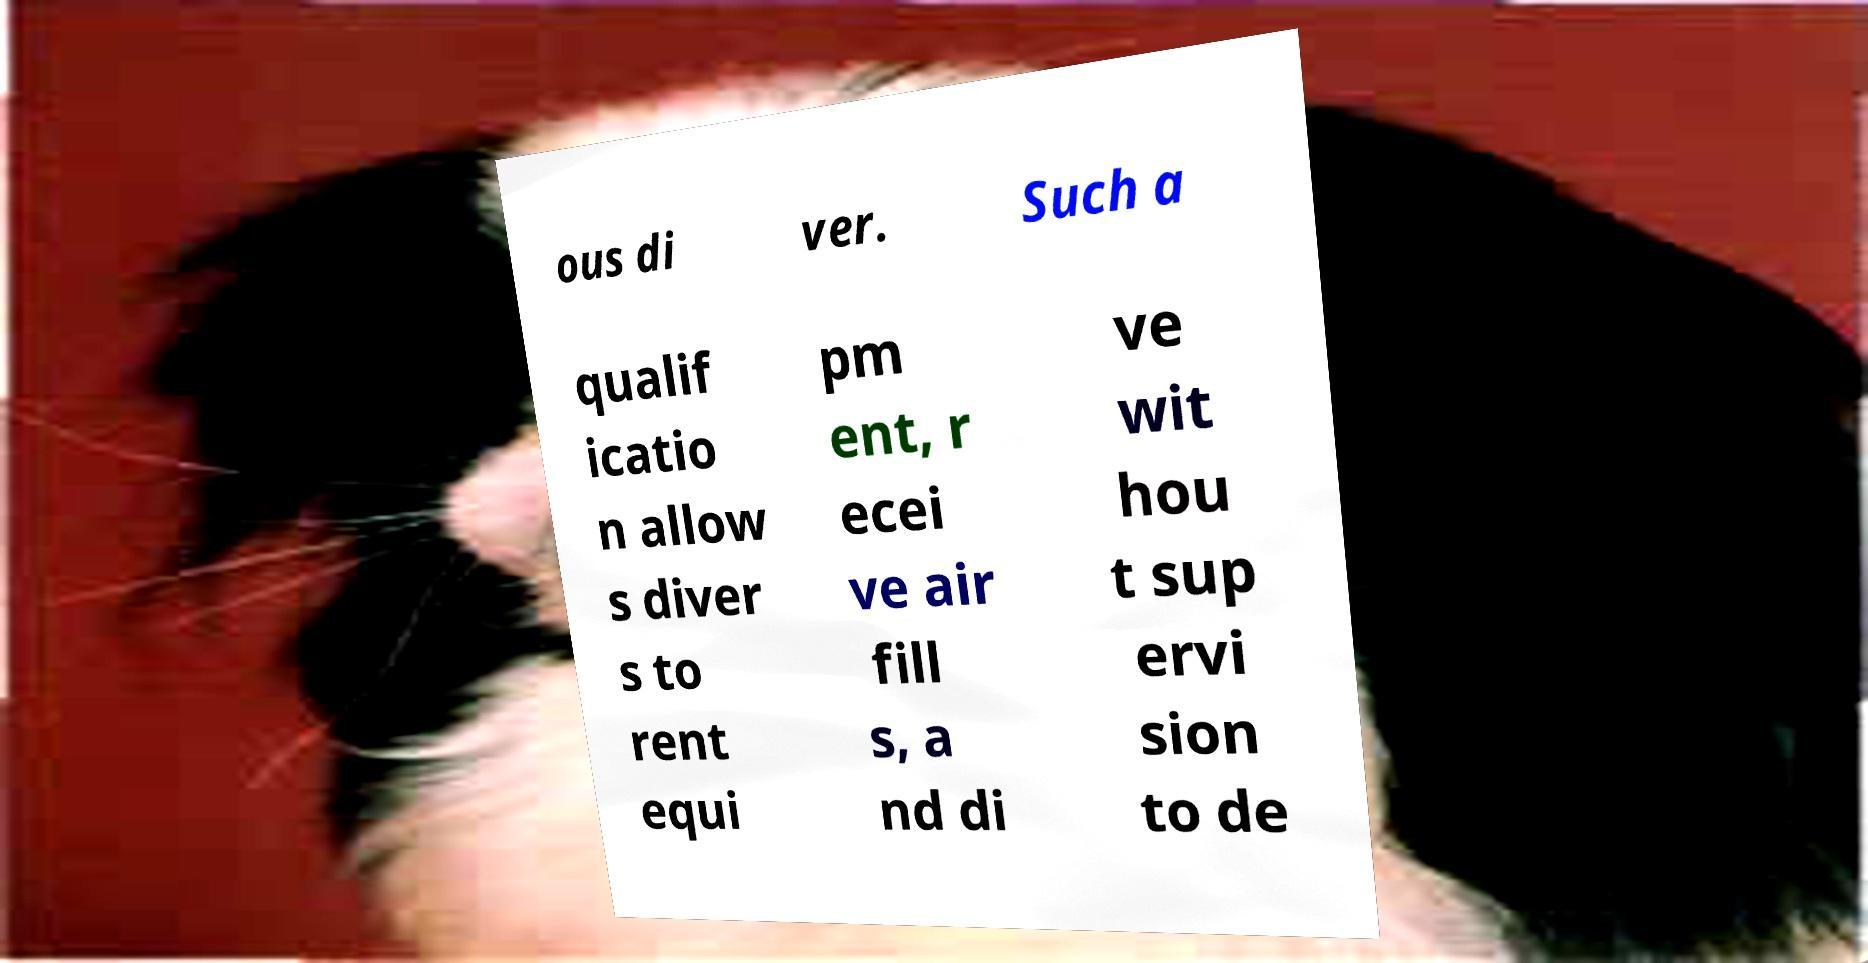Please read and relay the text visible in this image. What does it say? ous di ver. Such a qualif icatio n allow s diver s to rent equi pm ent, r ecei ve air fill s, a nd di ve wit hou t sup ervi sion to de 